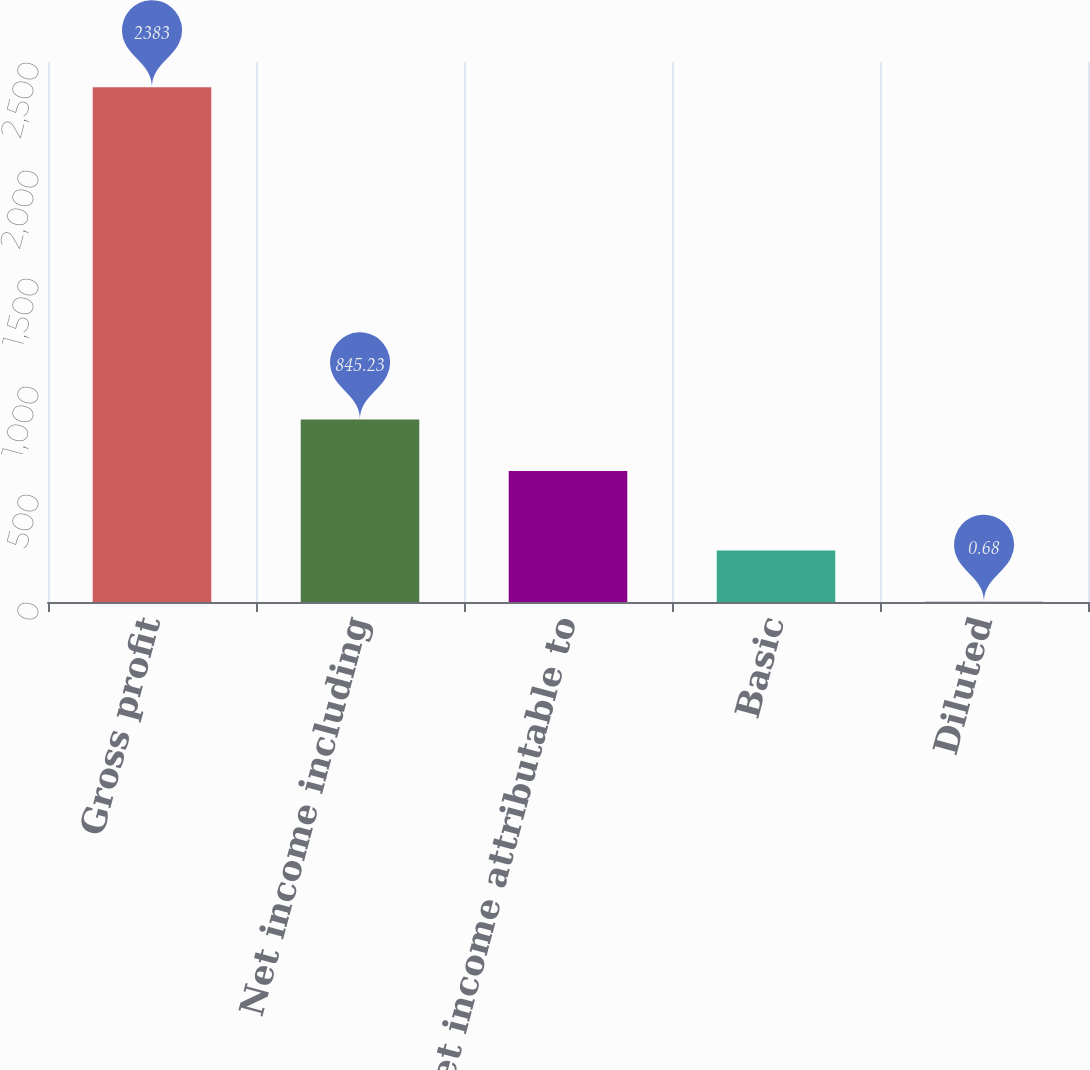<chart> <loc_0><loc_0><loc_500><loc_500><bar_chart><fcel>Gross profit<fcel>Net income including<fcel>Net income attributable to<fcel>Basic<fcel>Diluted<nl><fcel>2383<fcel>845.23<fcel>607<fcel>238.91<fcel>0.68<nl></chart> 